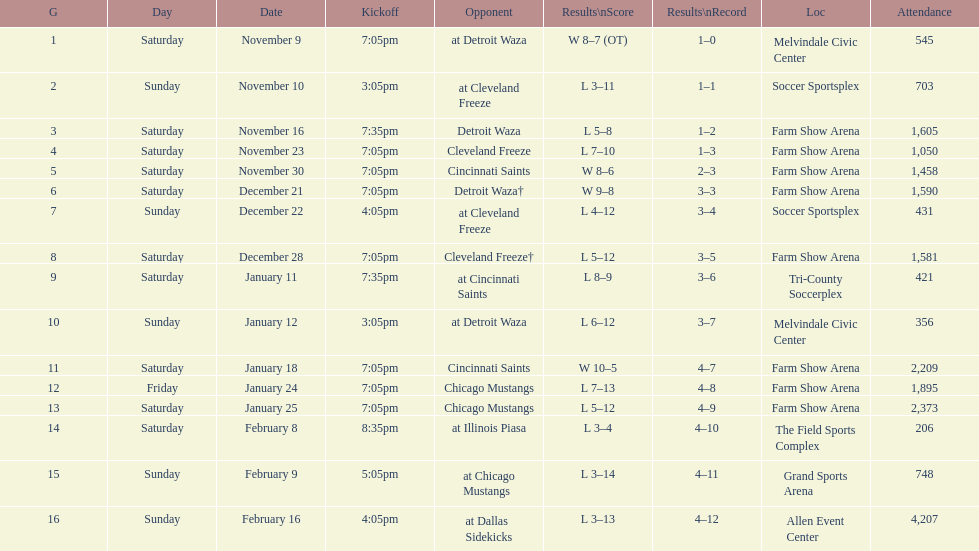What is the date of the game after december 22? December 28. Could you help me parse every detail presented in this table? {'header': ['G', 'Day', 'Date', 'Kickoff', 'Opponent', 'Results\\nScore', 'Results\\nRecord', 'Loc', 'Attendance'], 'rows': [['1', 'Saturday', 'November 9', '7:05pm', 'at Detroit Waza', 'W 8–7 (OT)', '1–0', 'Melvindale Civic Center', '545'], ['2', 'Sunday', 'November 10', '3:05pm', 'at Cleveland Freeze', 'L 3–11', '1–1', 'Soccer Sportsplex', '703'], ['3', 'Saturday', 'November 16', '7:35pm', 'Detroit Waza', 'L 5–8', '1–2', 'Farm Show Arena', '1,605'], ['4', 'Saturday', 'November 23', '7:05pm', 'Cleveland Freeze', 'L 7–10', '1–3', 'Farm Show Arena', '1,050'], ['5', 'Saturday', 'November 30', '7:05pm', 'Cincinnati Saints', 'W 8–6', '2–3', 'Farm Show Arena', '1,458'], ['6', 'Saturday', 'December 21', '7:05pm', 'Detroit Waza†', 'W 9–8', '3–3', 'Farm Show Arena', '1,590'], ['7', 'Sunday', 'December 22', '4:05pm', 'at Cleveland Freeze', 'L 4–12', '3–4', 'Soccer Sportsplex', '431'], ['8', 'Saturday', 'December 28', '7:05pm', 'Cleveland Freeze†', 'L 5–12', '3–5', 'Farm Show Arena', '1,581'], ['9', 'Saturday', 'January 11', '7:35pm', 'at Cincinnati Saints', 'L 8–9', '3–6', 'Tri-County Soccerplex', '421'], ['10', 'Sunday', 'January 12', '3:05pm', 'at Detroit Waza', 'L 6–12', '3–7', 'Melvindale Civic Center', '356'], ['11', 'Saturday', 'January 18', '7:05pm', 'Cincinnati Saints', 'W 10–5', '4–7', 'Farm Show Arena', '2,209'], ['12', 'Friday', 'January 24', '7:05pm', 'Chicago Mustangs', 'L 7–13', '4–8', 'Farm Show Arena', '1,895'], ['13', 'Saturday', 'January 25', '7:05pm', 'Chicago Mustangs', 'L 5–12', '4–9', 'Farm Show Arena', '2,373'], ['14', 'Saturday', 'February 8', '8:35pm', 'at Illinois Piasa', 'L 3–4', '4–10', 'The Field Sports Complex', '206'], ['15', 'Sunday', 'February 9', '5:05pm', 'at Chicago Mustangs', 'L 3–14', '4–11', 'Grand Sports Arena', '748'], ['16', 'Sunday', 'February 16', '4:05pm', 'at Dallas Sidekicks', 'L 3–13', '4–12', 'Allen Event Center', '4,207']]} 